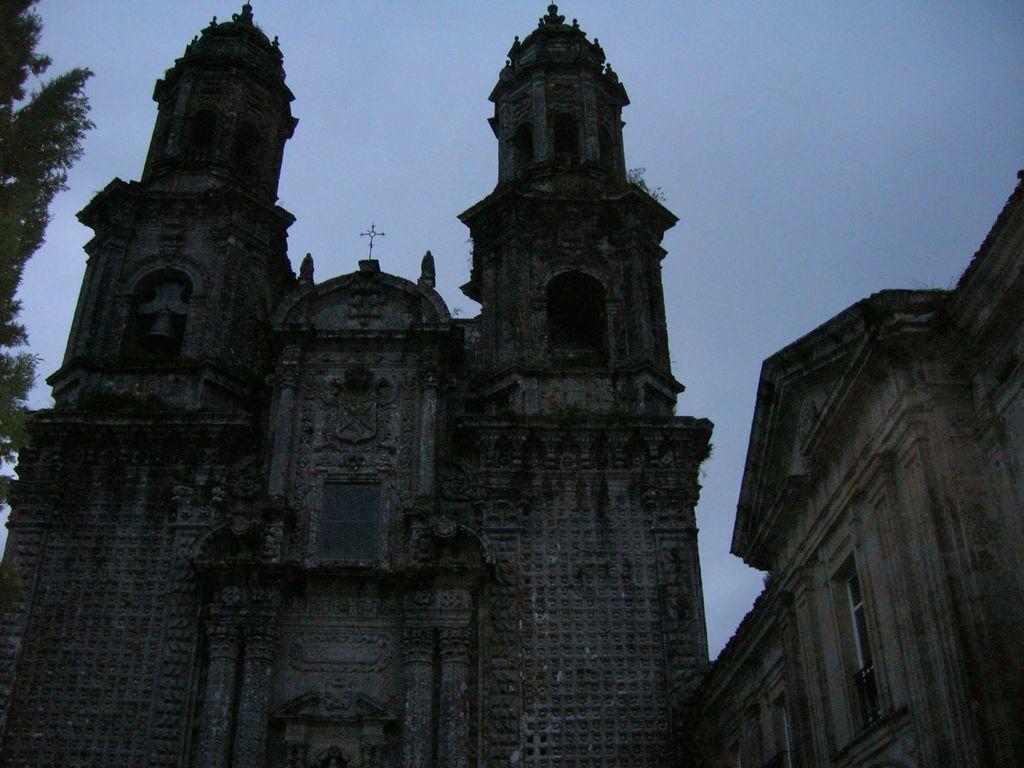In one or two sentences, can you explain what this image depicts? In this picture we can see an old architecture building and on the left side of the building there are trees and behind the building there is a sky. 